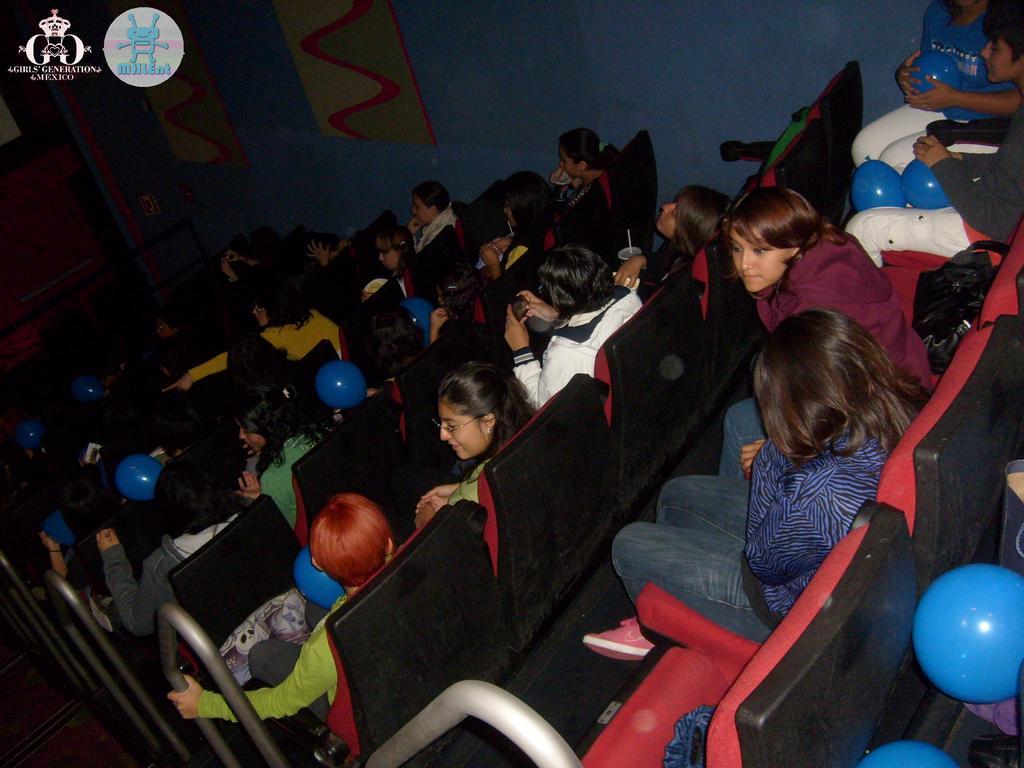Can you describe this image briefly? In the picture we can see many cars with children sitting on it and holding balloons which are blue in color and in the background, we can see a wall which is blue in color and some pictures to it. 